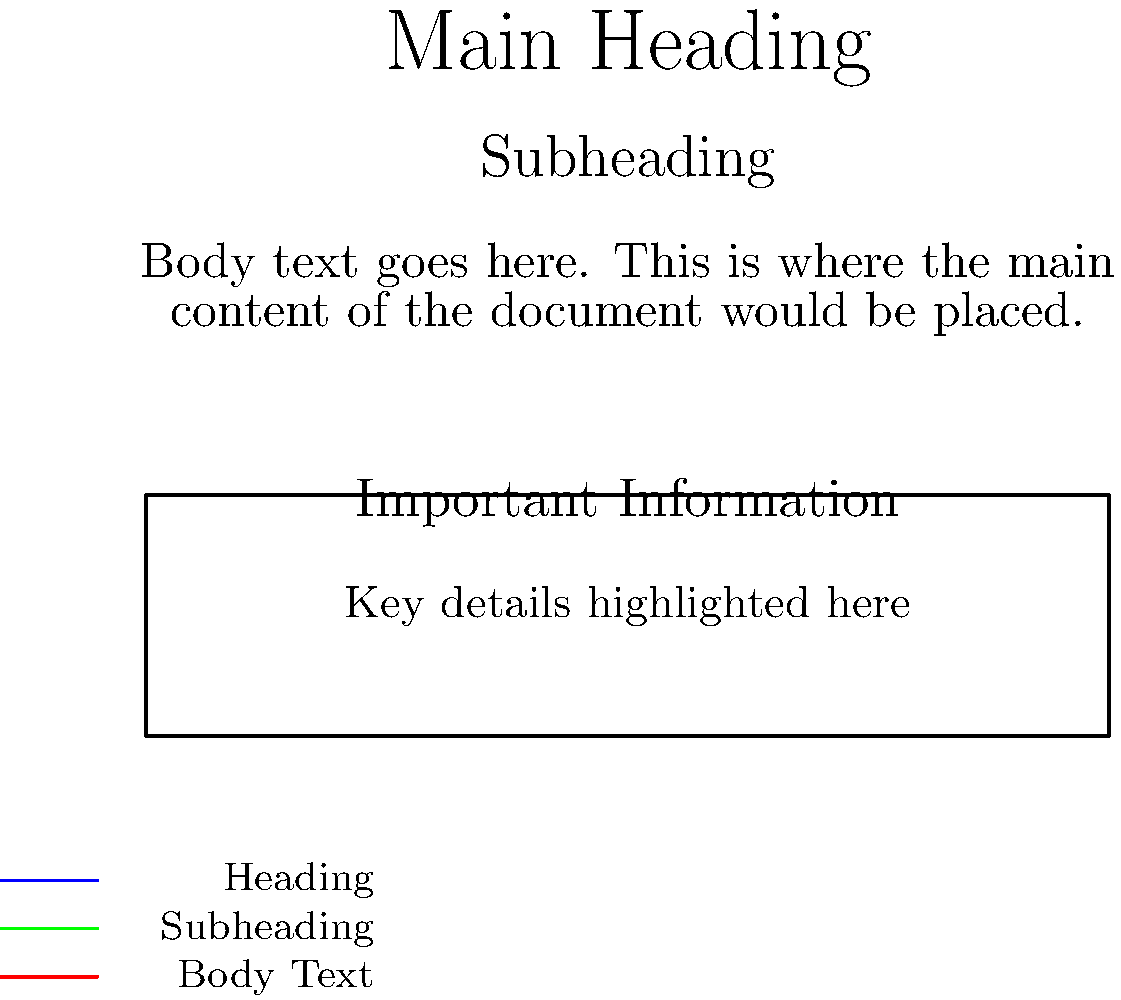As a professional digital designer, analyze the typography hierarchy in the given layout. Which element is most effectively emphasizing the information hierarchy, and why? To analyze the typography hierarchy in this layout, let's break it down step-by-step:

1. Main Heading: The largest font size (16pt) is used for the main heading, making it the most prominent element on the page.

2. Subheading: A slightly smaller font size (12pt) is used for the subheading, creating a clear distinction from the main heading while still being more prominent than the body text.

3. Body Text: The smallest font size (10pt) is used for the main content, appropriately subordinate to the headings.

4. Callout Box: 
   - Title: Uses a medium font size (11pt), drawing attention but not overpowering the main heading.
   - Content: Slightly smaller than the body text (9pt), indicating secondary importance.

5. Legend: The smallest font size (8pt) is used, as it's supplementary information.

The most effective element in emphasizing the information hierarchy is the font size variation. It creates a clear visual distinction between different levels of information:

- The main heading stands out the most, immediately drawing the reader's attention.
- The subheading is clearly secondary to the main heading but more important than the body text.
- The body text is easily distinguishable as the main content.
- The callout box uses size to highlight important information within the content.

This size hierarchy guides the reader's eye through the content in order of importance, effectively communicating the information structure.
Answer: Font size variation 